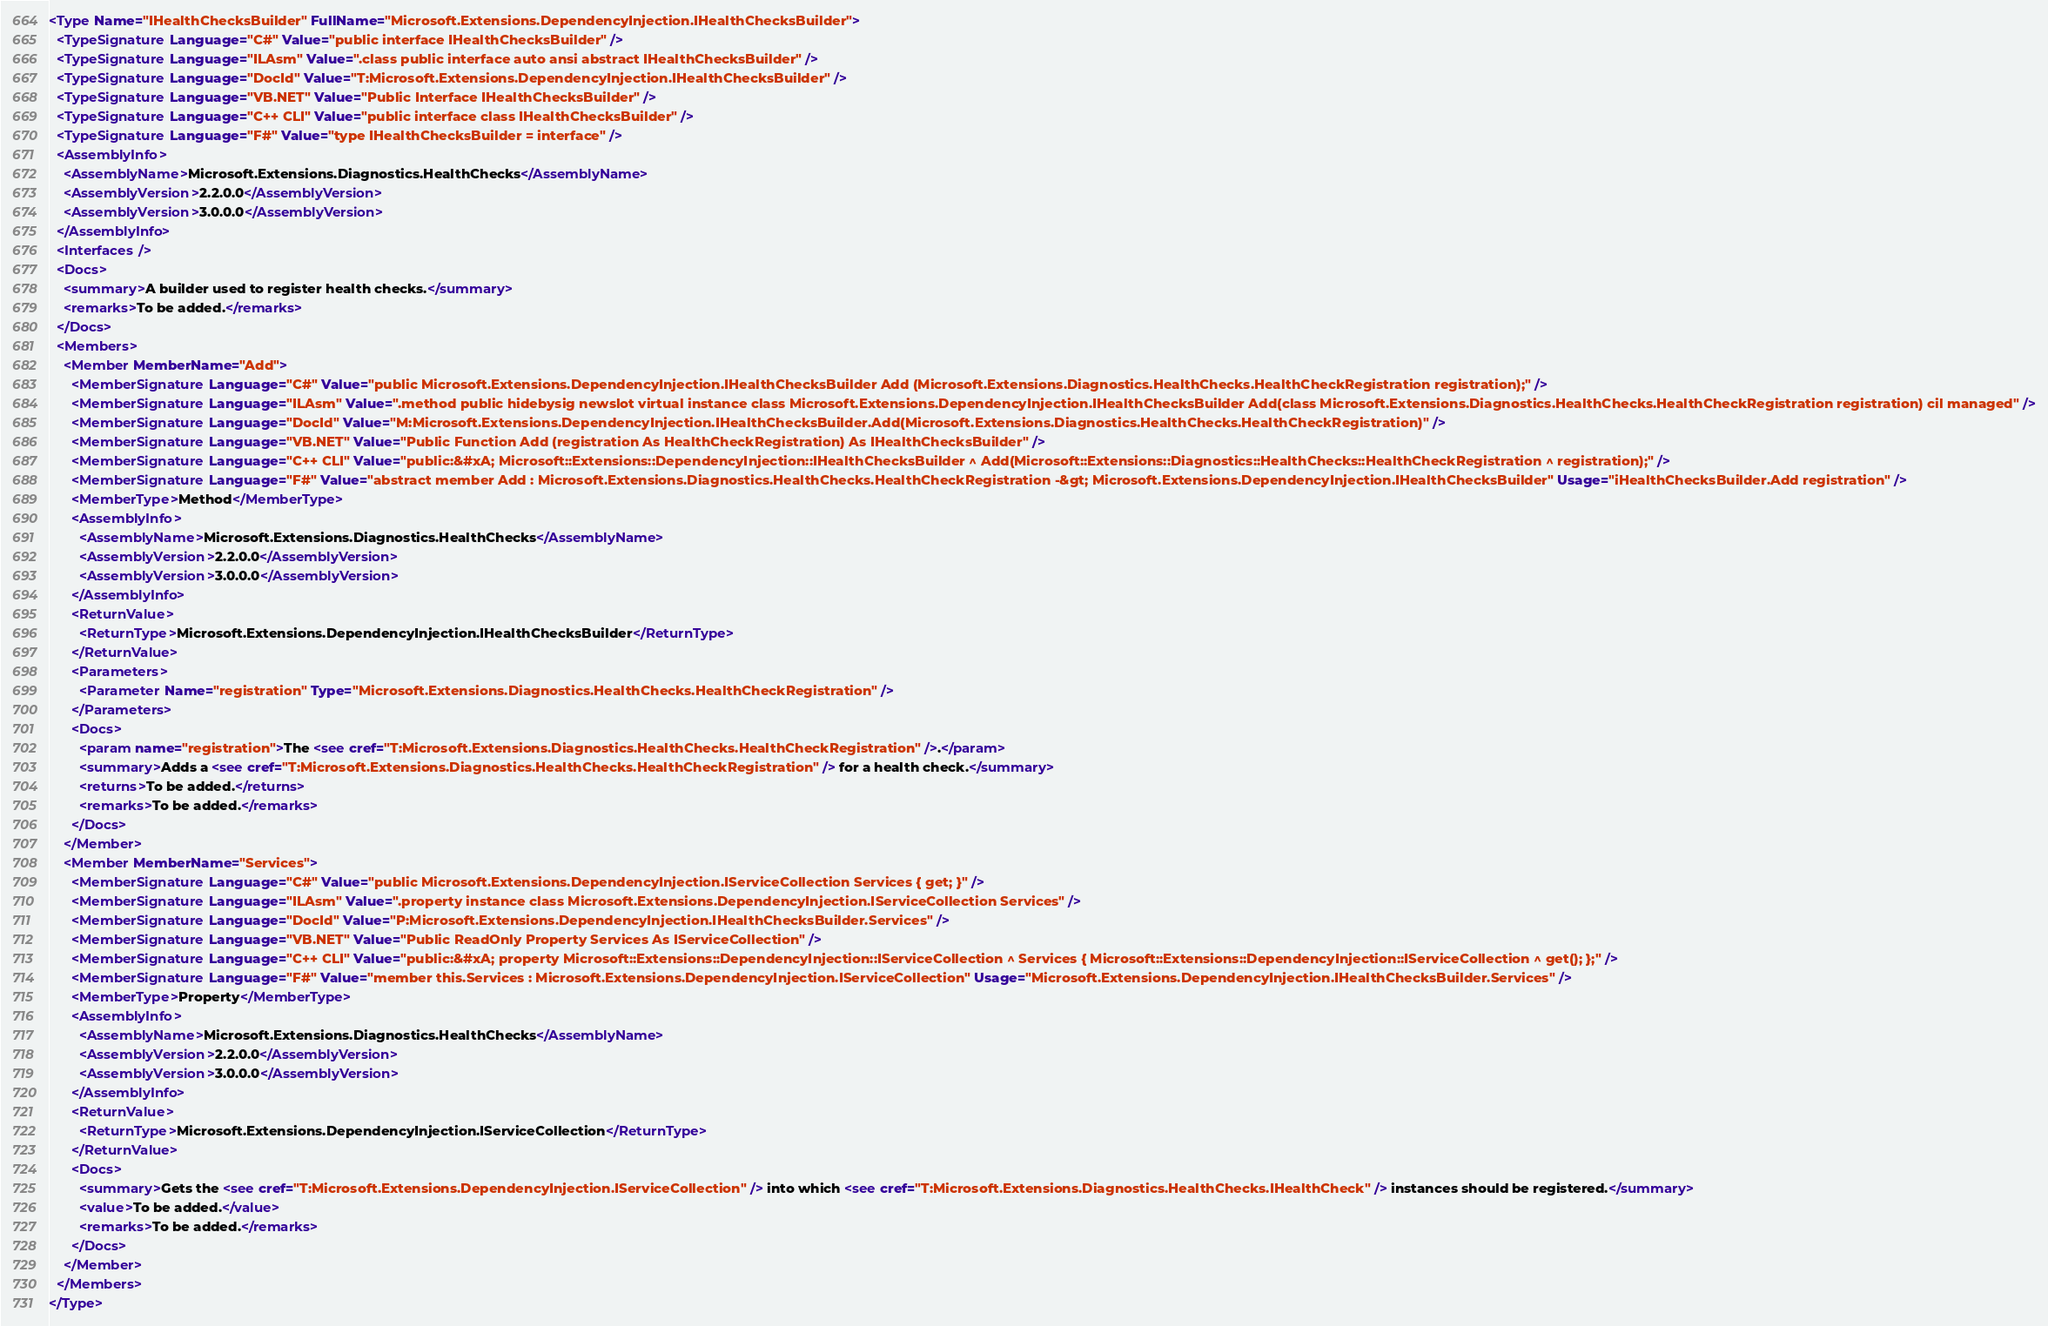<code> <loc_0><loc_0><loc_500><loc_500><_XML_><Type Name="IHealthChecksBuilder" FullName="Microsoft.Extensions.DependencyInjection.IHealthChecksBuilder">
  <TypeSignature Language="C#" Value="public interface IHealthChecksBuilder" />
  <TypeSignature Language="ILAsm" Value=".class public interface auto ansi abstract IHealthChecksBuilder" />
  <TypeSignature Language="DocId" Value="T:Microsoft.Extensions.DependencyInjection.IHealthChecksBuilder" />
  <TypeSignature Language="VB.NET" Value="Public Interface IHealthChecksBuilder" />
  <TypeSignature Language="C++ CLI" Value="public interface class IHealthChecksBuilder" />
  <TypeSignature Language="F#" Value="type IHealthChecksBuilder = interface" />
  <AssemblyInfo>
    <AssemblyName>Microsoft.Extensions.Diagnostics.HealthChecks</AssemblyName>
    <AssemblyVersion>2.2.0.0</AssemblyVersion>
    <AssemblyVersion>3.0.0.0</AssemblyVersion>
  </AssemblyInfo>
  <Interfaces />
  <Docs>
    <summary>A builder used to register health checks.</summary>
    <remarks>To be added.</remarks>
  </Docs>
  <Members>
    <Member MemberName="Add">
      <MemberSignature Language="C#" Value="public Microsoft.Extensions.DependencyInjection.IHealthChecksBuilder Add (Microsoft.Extensions.Diagnostics.HealthChecks.HealthCheckRegistration registration);" />
      <MemberSignature Language="ILAsm" Value=".method public hidebysig newslot virtual instance class Microsoft.Extensions.DependencyInjection.IHealthChecksBuilder Add(class Microsoft.Extensions.Diagnostics.HealthChecks.HealthCheckRegistration registration) cil managed" />
      <MemberSignature Language="DocId" Value="M:Microsoft.Extensions.DependencyInjection.IHealthChecksBuilder.Add(Microsoft.Extensions.Diagnostics.HealthChecks.HealthCheckRegistration)" />
      <MemberSignature Language="VB.NET" Value="Public Function Add (registration As HealthCheckRegistration) As IHealthChecksBuilder" />
      <MemberSignature Language="C++ CLI" Value="public:&#xA; Microsoft::Extensions::DependencyInjection::IHealthChecksBuilder ^ Add(Microsoft::Extensions::Diagnostics::HealthChecks::HealthCheckRegistration ^ registration);" />
      <MemberSignature Language="F#" Value="abstract member Add : Microsoft.Extensions.Diagnostics.HealthChecks.HealthCheckRegistration -&gt; Microsoft.Extensions.DependencyInjection.IHealthChecksBuilder" Usage="iHealthChecksBuilder.Add registration" />
      <MemberType>Method</MemberType>
      <AssemblyInfo>
        <AssemblyName>Microsoft.Extensions.Diagnostics.HealthChecks</AssemblyName>
        <AssemblyVersion>2.2.0.0</AssemblyVersion>
        <AssemblyVersion>3.0.0.0</AssemblyVersion>
      </AssemblyInfo>
      <ReturnValue>
        <ReturnType>Microsoft.Extensions.DependencyInjection.IHealthChecksBuilder</ReturnType>
      </ReturnValue>
      <Parameters>
        <Parameter Name="registration" Type="Microsoft.Extensions.Diagnostics.HealthChecks.HealthCheckRegistration" />
      </Parameters>
      <Docs>
        <param name="registration">The <see cref="T:Microsoft.Extensions.Diagnostics.HealthChecks.HealthCheckRegistration" />.</param>
        <summary>Adds a <see cref="T:Microsoft.Extensions.Diagnostics.HealthChecks.HealthCheckRegistration" /> for a health check.</summary>
        <returns>To be added.</returns>
        <remarks>To be added.</remarks>
      </Docs>
    </Member>
    <Member MemberName="Services">
      <MemberSignature Language="C#" Value="public Microsoft.Extensions.DependencyInjection.IServiceCollection Services { get; }" />
      <MemberSignature Language="ILAsm" Value=".property instance class Microsoft.Extensions.DependencyInjection.IServiceCollection Services" />
      <MemberSignature Language="DocId" Value="P:Microsoft.Extensions.DependencyInjection.IHealthChecksBuilder.Services" />
      <MemberSignature Language="VB.NET" Value="Public ReadOnly Property Services As IServiceCollection" />
      <MemberSignature Language="C++ CLI" Value="public:&#xA; property Microsoft::Extensions::DependencyInjection::IServiceCollection ^ Services { Microsoft::Extensions::DependencyInjection::IServiceCollection ^ get(); };" />
      <MemberSignature Language="F#" Value="member this.Services : Microsoft.Extensions.DependencyInjection.IServiceCollection" Usage="Microsoft.Extensions.DependencyInjection.IHealthChecksBuilder.Services" />
      <MemberType>Property</MemberType>
      <AssemblyInfo>
        <AssemblyName>Microsoft.Extensions.Diagnostics.HealthChecks</AssemblyName>
        <AssemblyVersion>2.2.0.0</AssemblyVersion>
        <AssemblyVersion>3.0.0.0</AssemblyVersion>
      </AssemblyInfo>
      <ReturnValue>
        <ReturnType>Microsoft.Extensions.DependencyInjection.IServiceCollection</ReturnType>
      </ReturnValue>
      <Docs>
        <summary>Gets the <see cref="T:Microsoft.Extensions.DependencyInjection.IServiceCollection" /> into which <see cref="T:Microsoft.Extensions.Diagnostics.HealthChecks.IHealthCheck" /> instances should be registered.</summary>
        <value>To be added.</value>
        <remarks>To be added.</remarks>
      </Docs>
    </Member>
  </Members>
</Type>
</code> 